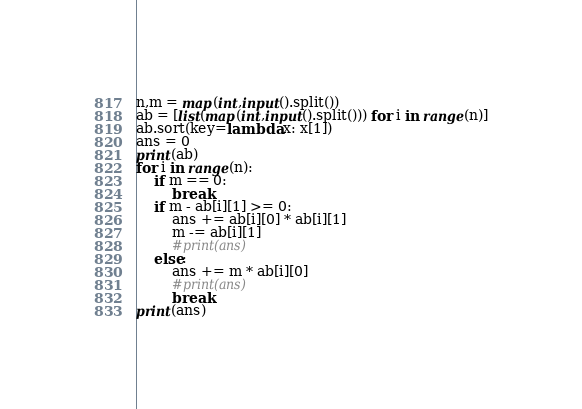Convert code to text. <code><loc_0><loc_0><loc_500><loc_500><_Python_>n,m = map(int,input().split())
ab = [list(map(int,input().split())) for i in range(n)]
ab.sort(key=lambda x: x[1])
ans = 0
print(ab)
for i in range(n):
    if m == 0:
        break
    if m - ab[i][1] >= 0:
        ans += ab[i][0] * ab[i][1]
        m -= ab[i][1]
        #print(ans)
    else:
        ans += m * ab[i][0]
        #print(ans)
        break
print(ans)
</code> 